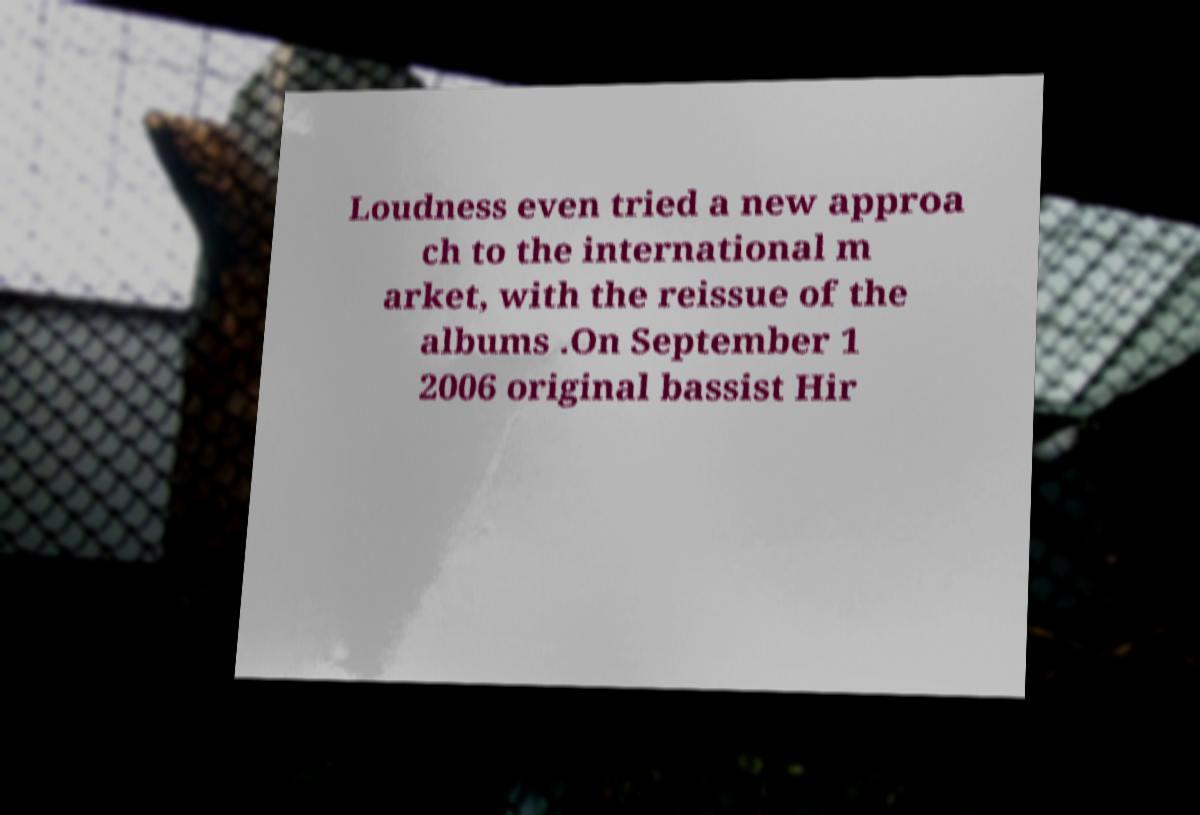Can you accurately transcribe the text from the provided image for me? Loudness even tried a new approa ch to the international m arket, with the reissue of the albums .On September 1 2006 original bassist Hir 